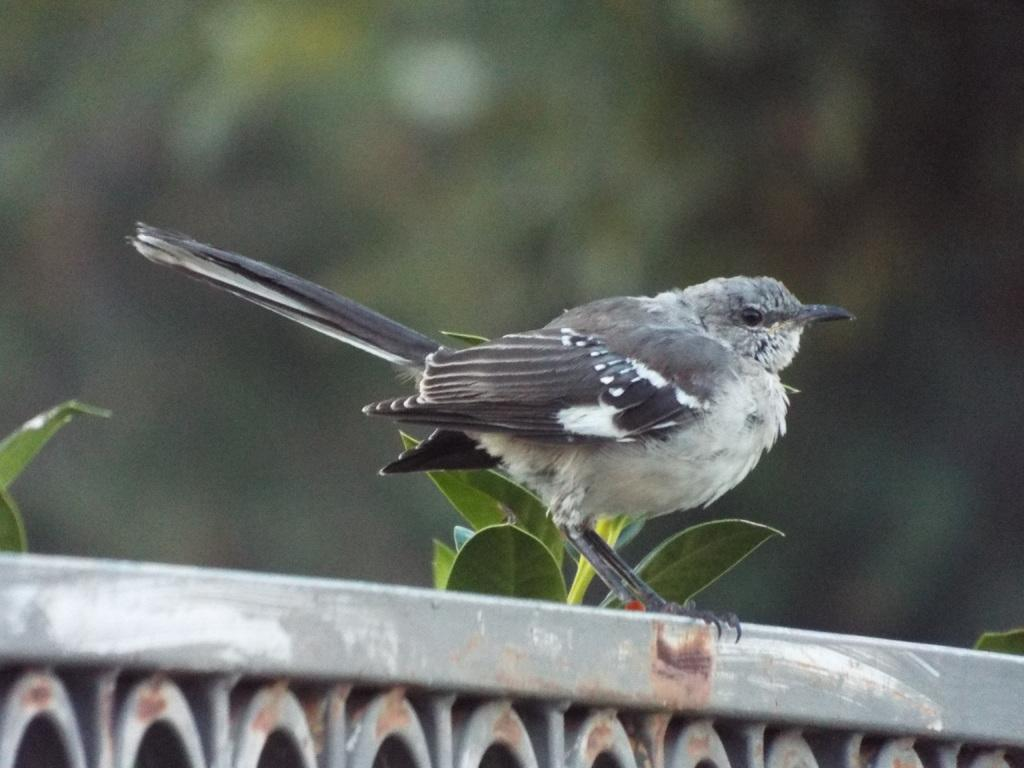What type of bird is in the image? There is a sparrow in the image. What else can be seen in the image besides the bird? There are leaves in the image. How would you describe the background of the image? The background of the image is blurred. What is at the bottom of the image? There is a railing at the bottom of the image. What color is the elbow of the sparrow in the image? There is no mention of an elbow in the description of the sparrow, as sparrows do not have elbows. 